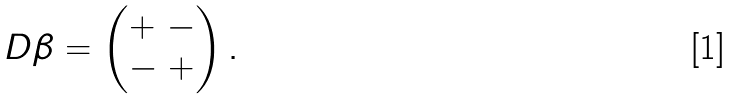<formula> <loc_0><loc_0><loc_500><loc_500>D \beta = \begin{pmatrix} + \ - \\ - \ + \end{pmatrix} .</formula> 